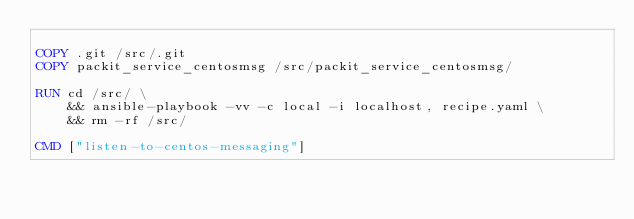Convert code to text. <code><loc_0><loc_0><loc_500><loc_500><_Dockerfile_>
COPY .git /src/.git
COPY packit_service_centosmsg /src/packit_service_centosmsg/

RUN cd /src/ \
    && ansible-playbook -vv -c local -i localhost, recipe.yaml \
    && rm -rf /src/

CMD ["listen-to-centos-messaging"]
</code> 